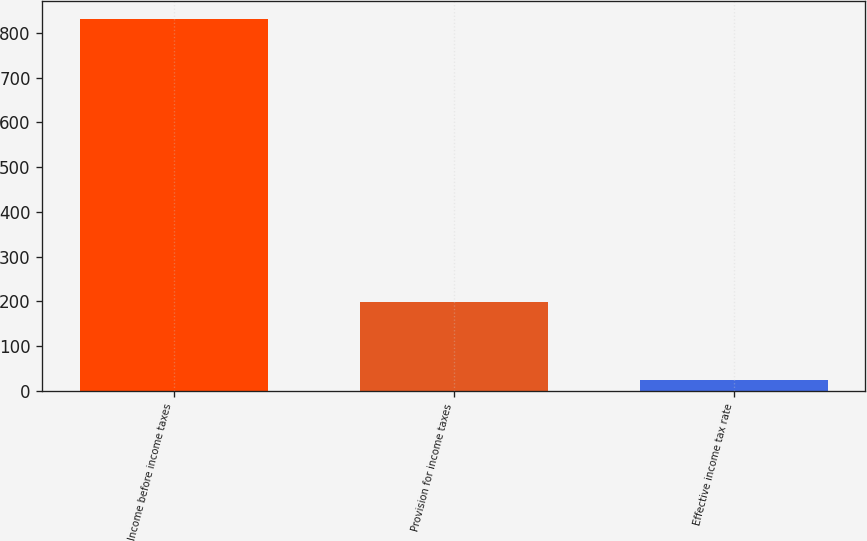Convert chart. <chart><loc_0><loc_0><loc_500><loc_500><bar_chart><fcel>Income before income taxes<fcel>Provision for income taxes<fcel>Effective income tax rate<nl><fcel>830.2<fcel>198<fcel>23.8<nl></chart> 